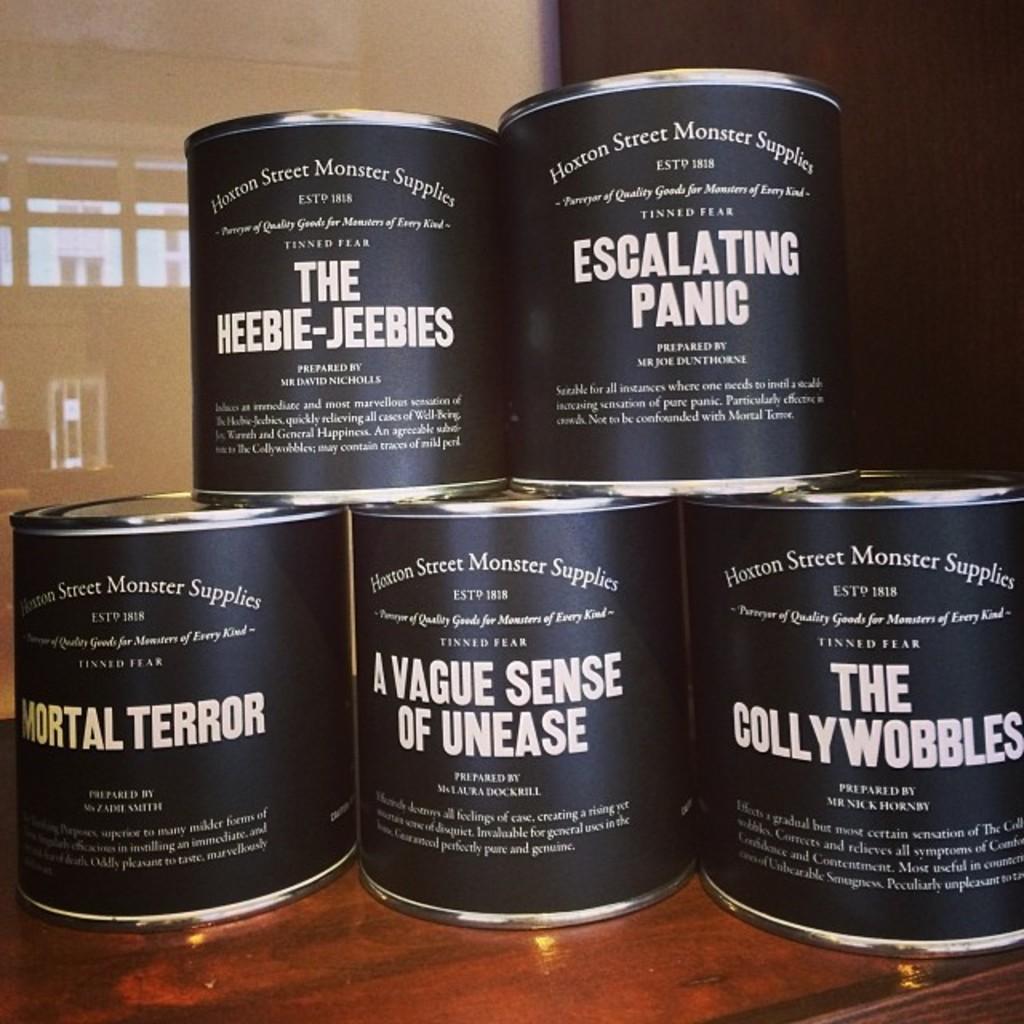What is the top right one?
Ensure brevity in your answer.  Escalating panic. 